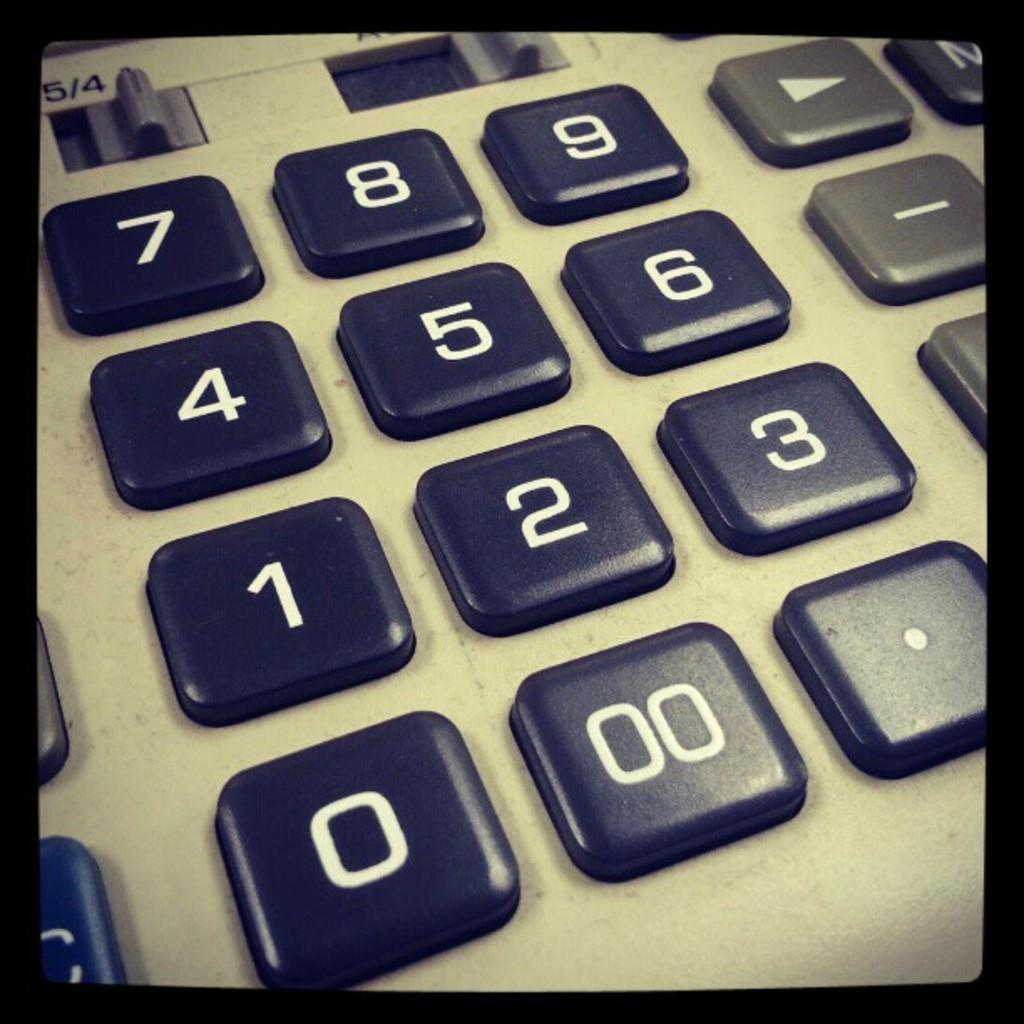<image>
Present a compact description of the photo's key features. Calculator showing 5/4 and numbers including 0 and 00. 